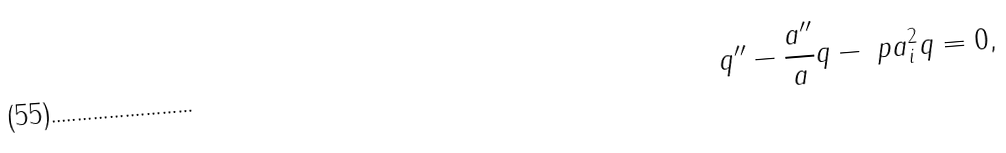<formula> <loc_0><loc_0><loc_500><loc_500>q ^ { \prime \prime } - \frac { a ^ { \prime \prime } } { a } q - \ p a _ { i } ^ { 2 } q = 0 ,</formula> 